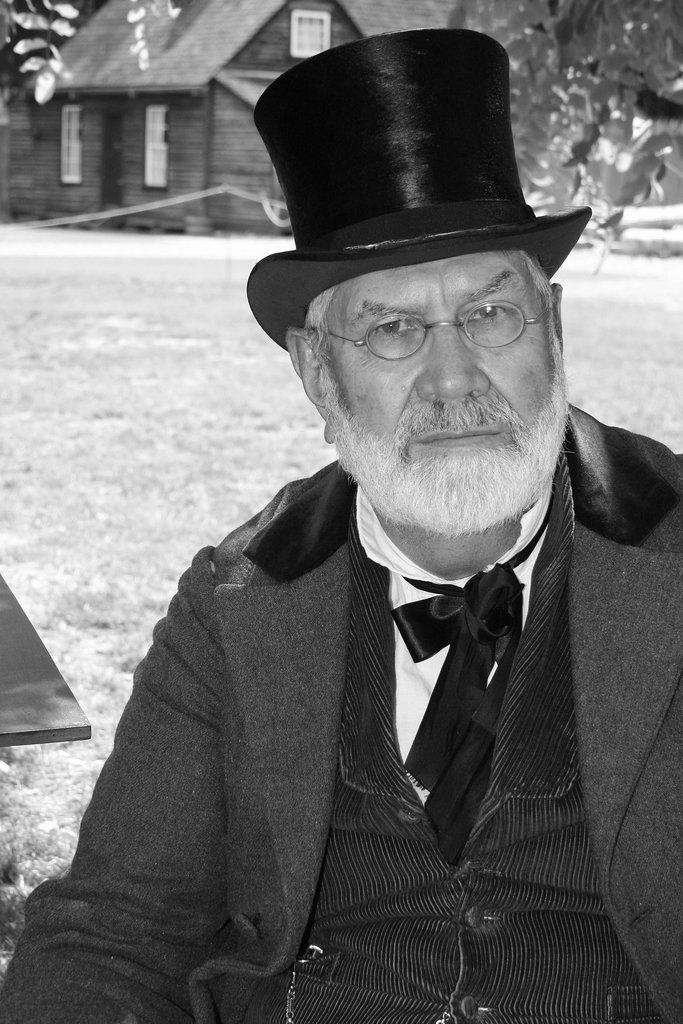Who or what is the main subject in the image? There is a person in the image. What is located behind the person? There is an object behind the person. What type of structure can be seen in the image? There is a wooden house in the image. What type of natural environment is visible in the image? There are trees in the image. What type of food is being served at the airport in the image? There is no airport or food present in the image. 